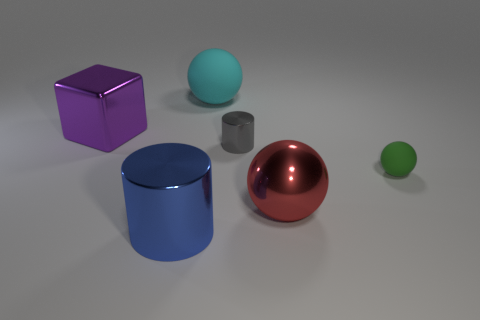How many objects are either metal cylinders that are left of the large cyan thing or cylinders that are in front of the small gray cylinder?
Make the answer very short. 1. There is a metal object that is behind the small green matte object and to the right of the big cyan sphere; what shape is it?
Provide a succinct answer. Cylinder. What number of tiny gray metallic cylinders are to the left of the big object behind the big purple block?
Offer a very short reply. 0. Are there any other things that have the same material as the big cyan sphere?
Your answer should be very brief. Yes. What number of objects are spheres in front of the small rubber object or green things?
Provide a succinct answer. 2. What is the size of the green object that is in front of the gray metal cylinder?
Ensure brevity in your answer.  Small. What is the big cyan thing made of?
Offer a very short reply. Rubber. The large shiny thing on the right side of the matte object behind the green thing is what shape?
Give a very brief answer. Sphere. How many other things are the same shape as the purple object?
Keep it short and to the point. 0. Are there any big metal cylinders right of the small green rubber object?
Provide a succinct answer. No. 